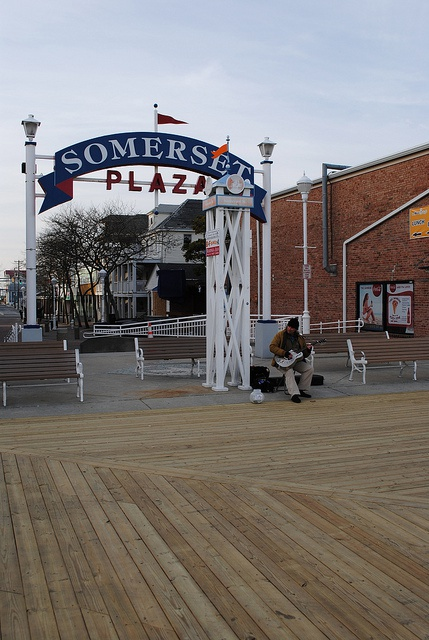Describe the objects in this image and their specific colors. I can see bench in lavender, black, gray, and darkgray tones, people in lavender, black, gray, and maroon tones, bench in lavender, gray, black, and maroon tones, bench in lavender, black, gray, and darkgray tones, and bench in lavender, black, and gray tones in this image. 